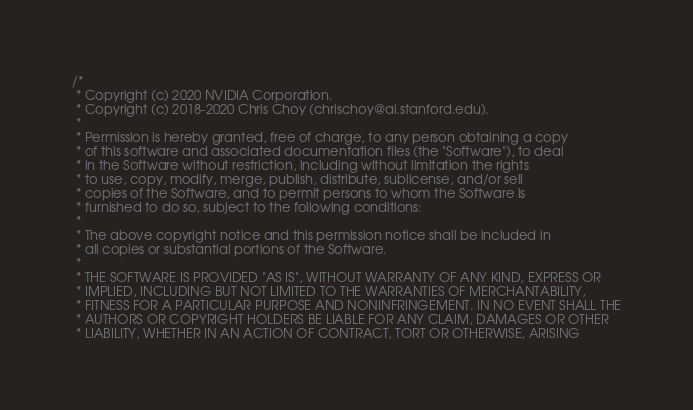Convert code to text. <code><loc_0><loc_0><loc_500><loc_500><_Cuda_>/*
 * Copyright (c) 2020 NVIDIA Corporation.
 * Copyright (c) 2018-2020 Chris Choy (chrischoy@ai.stanford.edu).
 *
 * Permission is hereby granted, free of charge, to any person obtaining a copy
 * of this software and associated documentation files (the "Software"), to deal
 * in the Software without restriction, including without limitation the rights
 * to use, copy, modify, merge, publish, distribute, sublicense, and/or sell
 * copies of the Software, and to permit persons to whom the Software is
 * furnished to do so, subject to the following conditions:
 *
 * The above copyright notice and this permission notice shall be included in
 * all copies or substantial portions of the Software.
 *
 * THE SOFTWARE IS PROVIDED "AS IS", WITHOUT WARRANTY OF ANY KIND, EXPRESS OR
 * IMPLIED, INCLUDING BUT NOT LIMITED TO THE WARRANTIES OF MERCHANTABILITY,
 * FITNESS FOR A PARTICULAR PURPOSE AND NONINFRINGEMENT. IN NO EVENT SHALL THE
 * AUTHORS OR COPYRIGHT HOLDERS BE LIABLE FOR ANY CLAIM, DAMAGES OR OTHER
 * LIABILITY, WHETHER IN AN ACTION OF CONTRACT, TORT OR OTHERWISE, ARISING</code> 